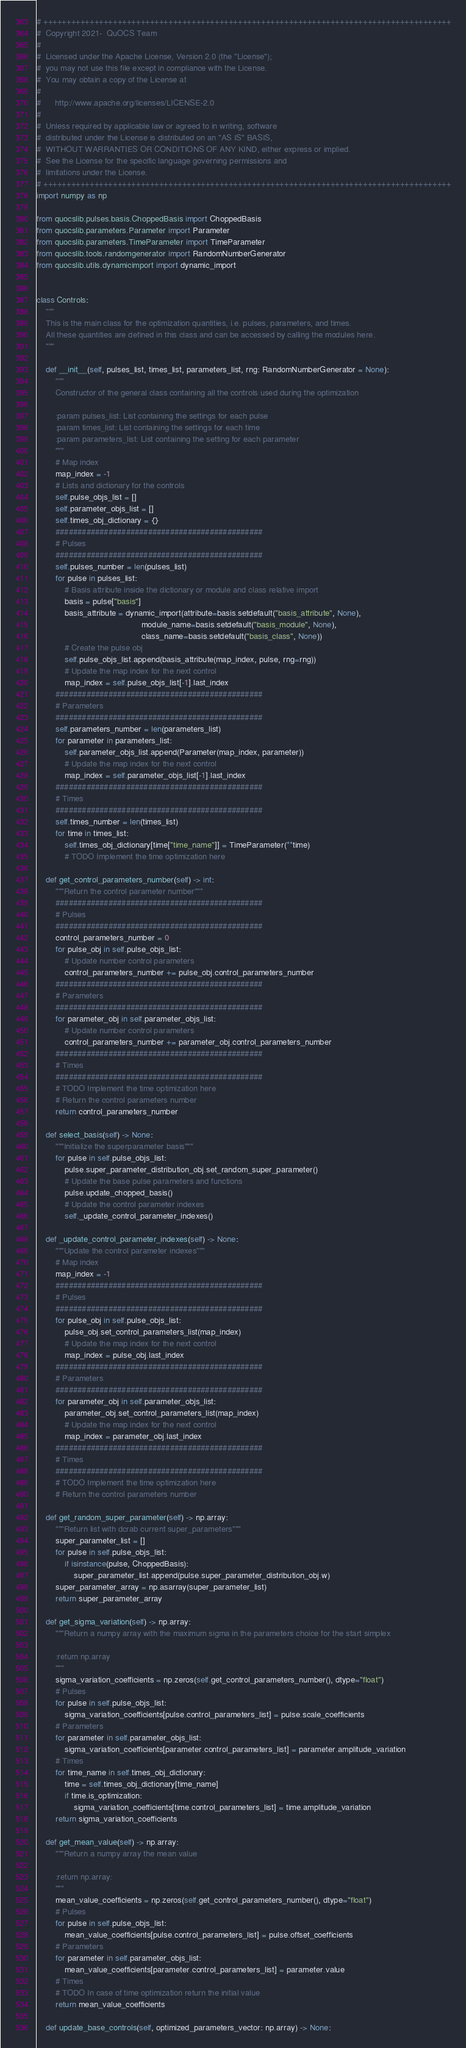<code> <loc_0><loc_0><loc_500><loc_500><_Python_># ++++++++++++++++++++++++++++++++++++++++++++++++++++++++++++++++++++++++++++++++++++++++
#  Copyright 2021-  QuOCS Team
#
#  Licensed under the Apache License, Version 2.0 (the "License");
#  you may not use this file except in compliance with the License.
#  You may obtain a copy of the License at
#
#      http://www.apache.org/licenses/LICENSE-2.0
#
#  Unless required by applicable law or agreed to in writing, software
#  distributed under the License is distributed on an "AS IS" BASIS,
#  WITHOUT WARRANTIES OR CONDITIONS OF ANY KIND, either express or implied.
#  See the License for the specific language governing permissions and
#  limitations under the License.
# ++++++++++++++++++++++++++++++++++++++++++++++++++++++++++++++++++++++++++++++++++++++++
import numpy as np

from quocslib.pulses.basis.ChoppedBasis import ChoppedBasis
from quocslib.parameters.Parameter import Parameter
from quocslib.parameters.TimeParameter import TimeParameter
from quocslib.tools.randomgenerator import RandomNumberGenerator
from quocslib.utils.dynamicimport import dynamic_import


class Controls:
    """
    This is the main class for the optimization quantities, i.e. pulses, parameters, and times.
    All these quantities are defined in this class and can be accessed by calling the modules here.
    """

    def __init__(self, pulses_list, times_list, parameters_list, rng: RandomNumberGenerator = None):
        """
        Constructor of the general class containing all the controls used during the optimization

        :param pulses_list: List containing the settings for each pulse
        :param times_list: List containing the settings for each time
        :param parameters_list: List containing the setting for each parameter
        """
        # Map index
        map_index = -1
        # Lists and dictionary for the controls
        self.pulse_objs_list = []
        self.parameter_objs_list = []
        self.times_obj_dictionary = {}
        ###############################################
        # Pulses
        ###############################################
        self.pulses_number = len(pulses_list)
        for pulse in pulses_list:
            # Basis attribute inside the dictionary or module and class relative import
            basis = pulse["basis"]
            basis_attribute = dynamic_import(attribute=basis.setdefault("basis_attribute", None),
                                             module_name=basis.setdefault("basis_module", None),
                                             class_name=basis.setdefault("basis_class", None))
            # Create the pulse obj
            self.pulse_objs_list.append(basis_attribute(map_index, pulse, rng=rng))
            # Update the map index for the next control
            map_index = self.pulse_objs_list[-1].last_index
        ###############################################
        # Parameters
        ###############################################
        self.parameters_number = len(parameters_list)
        for parameter in parameters_list:
            self.parameter_objs_list.append(Parameter(map_index, parameter))
            # Update the map index for the next control
            map_index = self.parameter_objs_list[-1].last_index
        ###############################################
        # Times
        ###############################################
        self.times_number = len(times_list)
        for time in times_list:
            self.times_obj_dictionary[time["time_name"]] = TimeParameter(**time)
            # TODO Implement the time optimization here

    def get_control_parameters_number(self) -> int:
        """Return the control parameter number"""
        ###############################################
        # Pulses
        ###############################################
        control_parameters_number = 0
        for pulse_obj in self.pulse_objs_list:
            # Update number control parameters
            control_parameters_number += pulse_obj.control_parameters_number
        ###############################################
        # Parameters
        ###############################################
        for parameter_obj in self.parameter_objs_list:
            # Update number control parameters
            control_parameters_number += parameter_obj.control_parameters_number
        ###############################################
        # Times
        ###############################################
        # TODO Implement the time optimization here
        # Return the control parameters number
        return control_parameters_number

    def select_basis(self) -> None:
        """Initialize the superparameter basis"""
        for pulse in self.pulse_objs_list:
            pulse.super_parameter_distribution_obj.set_random_super_parameter()
            # Update the base pulse parameters and functions
            pulse.update_chopped_basis()
            # Update the control parameter indexes
            self._update_control_parameter_indexes()

    def _update_control_parameter_indexes(self) -> None:
        """Update the control parameter indexes"""
        # Map index
        map_index = -1
        ###############################################
        # Pulses
        ###############################################
        for pulse_obj in self.pulse_objs_list:
            pulse_obj.set_control_parameters_list(map_index)
            # Update the map index for the next control
            map_index = pulse_obj.last_index
        ###############################################
        # Parameters
        ###############################################
        for parameter_obj in self.parameter_objs_list:
            parameter_obj.set_control_parameters_list(map_index)
            # Update the map index for the next control
            map_index = parameter_obj.last_index
        ###############################################
        # Times
        ###############################################
        # TODO Implement the time optimization here
        # Return the control parameters number

    def get_random_super_parameter(self) -> np.array:
        """Return list with dcrab current super_parameters"""
        super_parameter_list = []
        for pulse in self.pulse_objs_list:
            if isinstance(pulse, ChoppedBasis):
                super_parameter_list.append(pulse.super_parameter_distribution_obj.w)
        super_parameter_array = np.asarray(super_parameter_list)
        return super_parameter_array

    def get_sigma_variation(self) -> np.array:
        """Return a numpy array with the maximum sigma in the parameters choice for the start simplex

        :return np.array
        """
        sigma_variation_coefficients = np.zeros(self.get_control_parameters_number(), dtype="float")
        # Pulses
        for pulse in self.pulse_objs_list:
            sigma_variation_coefficients[pulse.control_parameters_list] = pulse.scale_coefficients
        # Parameters
        for parameter in self.parameter_objs_list:
            sigma_variation_coefficients[parameter.control_parameters_list] = parameter.amplitude_variation
        # Times
        for time_name in self.times_obj_dictionary:
            time = self.times_obj_dictionary[time_name]
            if time.is_optimization:
                sigma_variation_coefficients[time.control_parameters_list] = time.amplitude_variation
        return sigma_variation_coefficients

    def get_mean_value(self) -> np.array:
        """Return a numpy array the mean value

        :return np.array:
        """
        mean_value_coefficients = np.zeros(self.get_control_parameters_number(), dtype="float")
        # Pulses
        for pulse in self.pulse_objs_list:
            mean_value_coefficients[pulse.control_parameters_list] = pulse.offset_coefficients
        # Parameters
        for parameter in self.parameter_objs_list:
            mean_value_coefficients[parameter.control_parameters_list] = parameter.value
        # Times
        # TODO In case of time optimization return the initial value
        return mean_value_coefficients

    def update_base_controls(self, optimized_parameters_vector: np.array) -> None:</code> 